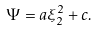Convert formula to latex. <formula><loc_0><loc_0><loc_500><loc_500>\Psi = a \xi _ { 2 } ^ { 2 } + c .</formula> 